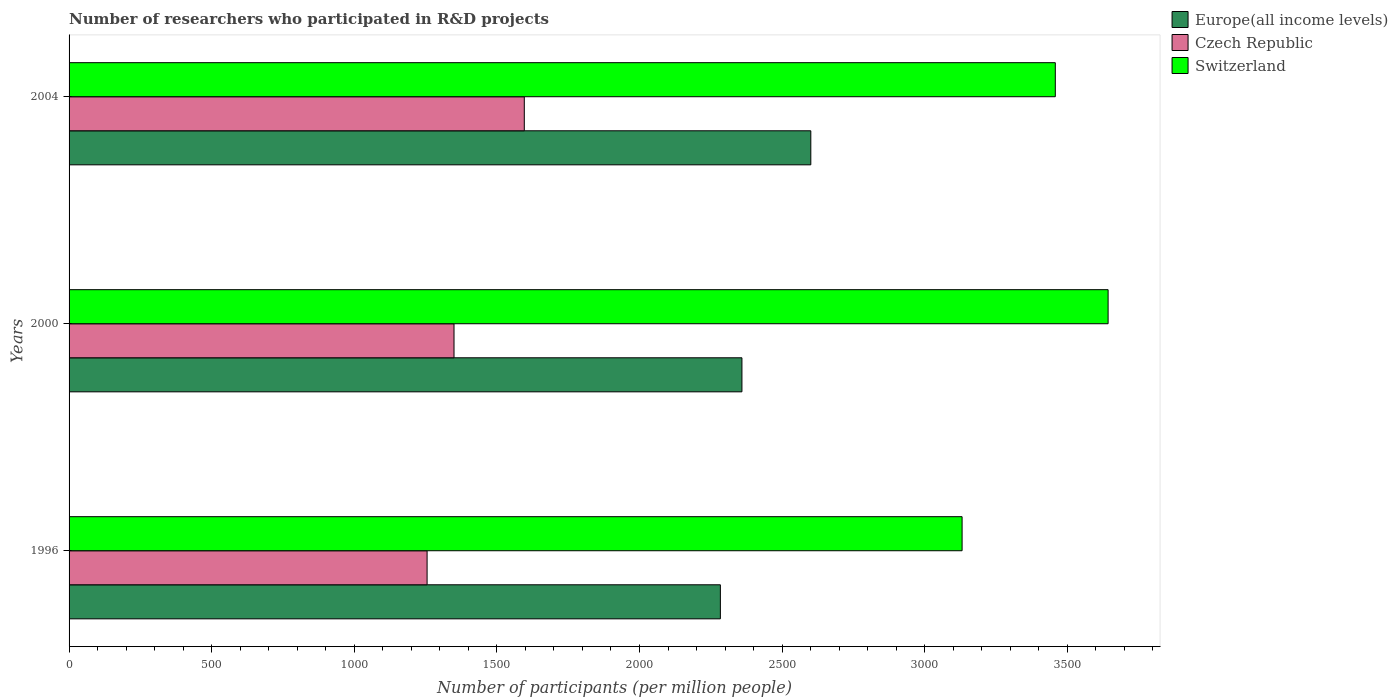How many different coloured bars are there?
Provide a short and direct response. 3. How many groups of bars are there?
Give a very brief answer. 3. Are the number of bars per tick equal to the number of legend labels?
Offer a terse response. Yes. Are the number of bars on each tick of the Y-axis equal?
Ensure brevity in your answer.  Yes. What is the label of the 1st group of bars from the top?
Ensure brevity in your answer.  2004. What is the number of researchers who participated in R&D projects in Switzerland in 1996?
Ensure brevity in your answer.  3131.18. Across all years, what is the maximum number of researchers who participated in R&D projects in Switzerland?
Provide a short and direct response. 3643.11. Across all years, what is the minimum number of researchers who participated in R&D projects in Czech Republic?
Provide a succinct answer. 1255.29. In which year was the number of researchers who participated in R&D projects in Czech Republic maximum?
Your answer should be very brief. 2004. In which year was the number of researchers who participated in R&D projects in Switzerland minimum?
Keep it short and to the point. 1996. What is the total number of researchers who participated in R&D projects in Czech Republic in the graph?
Ensure brevity in your answer.  4201.11. What is the difference between the number of researchers who participated in R&D projects in Czech Republic in 1996 and that in 2000?
Your answer should be compact. -94.41. What is the difference between the number of researchers who participated in R&D projects in Europe(all income levels) in 1996 and the number of researchers who participated in R&D projects in Czech Republic in 2000?
Offer a terse response. 933.93. What is the average number of researchers who participated in R&D projects in Europe(all income levels) per year?
Keep it short and to the point. 2414.52. In the year 1996, what is the difference between the number of researchers who participated in R&D projects in Switzerland and number of researchers who participated in R&D projects in Czech Republic?
Make the answer very short. 1875.89. In how many years, is the number of researchers who participated in R&D projects in Europe(all income levels) greater than 1600 ?
Your answer should be compact. 3. What is the ratio of the number of researchers who participated in R&D projects in Switzerland in 1996 to that in 2004?
Your answer should be very brief. 0.91. Is the difference between the number of researchers who participated in R&D projects in Switzerland in 1996 and 2000 greater than the difference between the number of researchers who participated in R&D projects in Czech Republic in 1996 and 2000?
Provide a succinct answer. No. What is the difference between the highest and the second highest number of researchers who participated in R&D projects in Switzerland?
Provide a short and direct response. 185.12. What is the difference between the highest and the lowest number of researchers who participated in R&D projects in Switzerland?
Your answer should be very brief. 511.93. Is the sum of the number of researchers who participated in R&D projects in Europe(all income levels) in 2000 and 2004 greater than the maximum number of researchers who participated in R&D projects in Switzerland across all years?
Offer a terse response. Yes. What does the 2nd bar from the top in 2000 represents?
Ensure brevity in your answer.  Czech Republic. What does the 3rd bar from the bottom in 2000 represents?
Offer a terse response. Switzerland. Is it the case that in every year, the sum of the number of researchers who participated in R&D projects in Europe(all income levels) and number of researchers who participated in R&D projects in Switzerland is greater than the number of researchers who participated in R&D projects in Czech Republic?
Ensure brevity in your answer.  Yes. How many years are there in the graph?
Your response must be concise. 3. What is the difference between two consecutive major ticks on the X-axis?
Make the answer very short. 500. Are the values on the major ticks of X-axis written in scientific E-notation?
Provide a short and direct response. No. Does the graph contain any zero values?
Keep it short and to the point. No. Does the graph contain grids?
Keep it short and to the point. No. How many legend labels are there?
Offer a very short reply. 3. How are the legend labels stacked?
Offer a very short reply. Vertical. What is the title of the graph?
Your answer should be very brief. Number of researchers who participated in R&D projects. What is the label or title of the X-axis?
Provide a short and direct response. Number of participants (per million people). What is the label or title of the Y-axis?
Give a very brief answer. Years. What is the Number of participants (per million people) of Europe(all income levels) in 1996?
Give a very brief answer. 2283.63. What is the Number of participants (per million people) in Czech Republic in 1996?
Your answer should be compact. 1255.29. What is the Number of participants (per million people) in Switzerland in 1996?
Provide a succinct answer. 3131.18. What is the Number of participants (per million people) of Europe(all income levels) in 2000?
Offer a very short reply. 2359.22. What is the Number of participants (per million people) of Czech Republic in 2000?
Offer a terse response. 1349.7. What is the Number of participants (per million people) of Switzerland in 2000?
Your answer should be very brief. 3643.11. What is the Number of participants (per million people) of Europe(all income levels) in 2004?
Provide a succinct answer. 2600.71. What is the Number of participants (per million people) of Czech Republic in 2004?
Offer a terse response. 1596.12. What is the Number of participants (per million people) in Switzerland in 2004?
Give a very brief answer. 3457.99. Across all years, what is the maximum Number of participants (per million people) of Europe(all income levels)?
Give a very brief answer. 2600.71. Across all years, what is the maximum Number of participants (per million people) of Czech Republic?
Ensure brevity in your answer.  1596.12. Across all years, what is the maximum Number of participants (per million people) in Switzerland?
Provide a succinct answer. 3643.11. Across all years, what is the minimum Number of participants (per million people) of Europe(all income levels)?
Keep it short and to the point. 2283.63. Across all years, what is the minimum Number of participants (per million people) in Czech Republic?
Provide a succinct answer. 1255.29. Across all years, what is the minimum Number of participants (per million people) of Switzerland?
Your response must be concise. 3131.18. What is the total Number of participants (per million people) in Europe(all income levels) in the graph?
Your answer should be compact. 7243.57. What is the total Number of participants (per million people) of Czech Republic in the graph?
Provide a short and direct response. 4201.11. What is the total Number of participants (per million people) of Switzerland in the graph?
Offer a terse response. 1.02e+04. What is the difference between the Number of participants (per million people) in Europe(all income levels) in 1996 and that in 2000?
Your answer should be compact. -75.59. What is the difference between the Number of participants (per million people) of Czech Republic in 1996 and that in 2000?
Your answer should be compact. -94.41. What is the difference between the Number of participants (per million people) in Switzerland in 1996 and that in 2000?
Your answer should be very brief. -511.93. What is the difference between the Number of participants (per million people) in Europe(all income levels) in 1996 and that in 2004?
Provide a succinct answer. -317.08. What is the difference between the Number of participants (per million people) in Czech Republic in 1996 and that in 2004?
Offer a very short reply. -340.82. What is the difference between the Number of participants (per million people) of Switzerland in 1996 and that in 2004?
Your response must be concise. -326.81. What is the difference between the Number of participants (per million people) of Europe(all income levels) in 2000 and that in 2004?
Offer a very short reply. -241.49. What is the difference between the Number of participants (per million people) in Czech Republic in 2000 and that in 2004?
Your response must be concise. -246.41. What is the difference between the Number of participants (per million people) of Switzerland in 2000 and that in 2004?
Provide a short and direct response. 185.12. What is the difference between the Number of participants (per million people) in Europe(all income levels) in 1996 and the Number of participants (per million people) in Czech Republic in 2000?
Offer a terse response. 933.93. What is the difference between the Number of participants (per million people) in Europe(all income levels) in 1996 and the Number of participants (per million people) in Switzerland in 2000?
Make the answer very short. -1359.48. What is the difference between the Number of participants (per million people) in Czech Republic in 1996 and the Number of participants (per million people) in Switzerland in 2000?
Your answer should be compact. -2387.82. What is the difference between the Number of participants (per million people) in Europe(all income levels) in 1996 and the Number of participants (per million people) in Czech Republic in 2004?
Your response must be concise. 687.52. What is the difference between the Number of participants (per million people) in Europe(all income levels) in 1996 and the Number of participants (per million people) in Switzerland in 2004?
Provide a short and direct response. -1174.36. What is the difference between the Number of participants (per million people) of Czech Republic in 1996 and the Number of participants (per million people) of Switzerland in 2004?
Ensure brevity in your answer.  -2202.7. What is the difference between the Number of participants (per million people) in Europe(all income levels) in 2000 and the Number of participants (per million people) in Czech Republic in 2004?
Your answer should be compact. 763.11. What is the difference between the Number of participants (per million people) in Europe(all income levels) in 2000 and the Number of participants (per million people) in Switzerland in 2004?
Your answer should be compact. -1098.77. What is the difference between the Number of participants (per million people) of Czech Republic in 2000 and the Number of participants (per million people) of Switzerland in 2004?
Make the answer very short. -2108.29. What is the average Number of participants (per million people) of Europe(all income levels) per year?
Give a very brief answer. 2414.52. What is the average Number of participants (per million people) in Czech Republic per year?
Make the answer very short. 1400.37. What is the average Number of participants (per million people) of Switzerland per year?
Offer a very short reply. 3410.76. In the year 1996, what is the difference between the Number of participants (per million people) in Europe(all income levels) and Number of participants (per million people) in Czech Republic?
Provide a short and direct response. 1028.34. In the year 1996, what is the difference between the Number of participants (per million people) of Europe(all income levels) and Number of participants (per million people) of Switzerland?
Ensure brevity in your answer.  -847.55. In the year 1996, what is the difference between the Number of participants (per million people) of Czech Republic and Number of participants (per million people) of Switzerland?
Provide a short and direct response. -1875.89. In the year 2000, what is the difference between the Number of participants (per million people) of Europe(all income levels) and Number of participants (per million people) of Czech Republic?
Provide a short and direct response. 1009.52. In the year 2000, what is the difference between the Number of participants (per million people) in Europe(all income levels) and Number of participants (per million people) in Switzerland?
Give a very brief answer. -1283.89. In the year 2000, what is the difference between the Number of participants (per million people) in Czech Republic and Number of participants (per million people) in Switzerland?
Your answer should be very brief. -2293.41. In the year 2004, what is the difference between the Number of participants (per million people) in Europe(all income levels) and Number of participants (per million people) in Czech Republic?
Give a very brief answer. 1004.6. In the year 2004, what is the difference between the Number of participants (per million people) in Europe(all income levels) and Number of participants (per million people) in Switzerland?
Provide a short and direct response. -857.28. In the year 2004, what is the difference between the Number of participants (per million people) in Czech Republic and Number of participants (per million people) in Switzerland?
Offer a very short reply. -1861.88. What is the ratio of the Number of participants (per million people) in Europe(all income levels) in 1996 to that in 2000?
Your response must be concise. 0.97. What is the ratio of the Number of participants (per million people) in Czech Republic in 1996 to that in 2000?
Offer a terse response. 0.93. What is the ratio of the Number of participants (per million people) of Switzerland in 1996 to that in 2000?
Your answer should be very brief. 0.86. What is the ratio of the Number of participants (per million people) in Europe(all income levels) in 1996 to that in 2004?
Your answer should be compact. 0.88. What is the ratio of the Number of participants (per million people) in Czech Republic in 1996 to that in 2004?
Your answer should be compact. 0.79. What is the ratio of the Number of participants (per million people) in Switzerland in 1996 to that in 2004?
Ensure brevity in your answer.  0.91. What is the ratio of the Number of participants (per million people) in Europe(all income levels) in 2000 to that in 2004?
Provide a short and direct response. 0.91. What is the ratio of the Number of participants (per million people) in Czech Republic in 2000 to that in 2004?
Provide a short and direct response. 0.85. What is the ratio of the Number of participants (per million people) of Switzerland in 2000 to that in 2004?
Ensure brevity in your answer.  1.05. What is the difference between the highest and the second highest Number of participants (per million people) of Europe(all income levels)?
Give a very brief answer. 241.49. What is the difference between the highest and the second highest Number of participants (per million people) in Czech Republic?
Make the answer very short. 246.41. What is the difference between the highest and the second highest Number of participants (per million people) in Switzerland?
Give a very brief answer. 185.12. What is the difference between the highest and the lowest Number of participants (per million people) of Europe(all income levels)?
Provide a succinct answer. 317.08. What is the difference between the highest and the lowest Number of participants (per million people) in Czech Republic?
Your answer should be compact. 340.82. What is the difference between the highest and the lowest Number of participants (per million people) in Switzerland?
Provide a short and direct response. 511.93. 